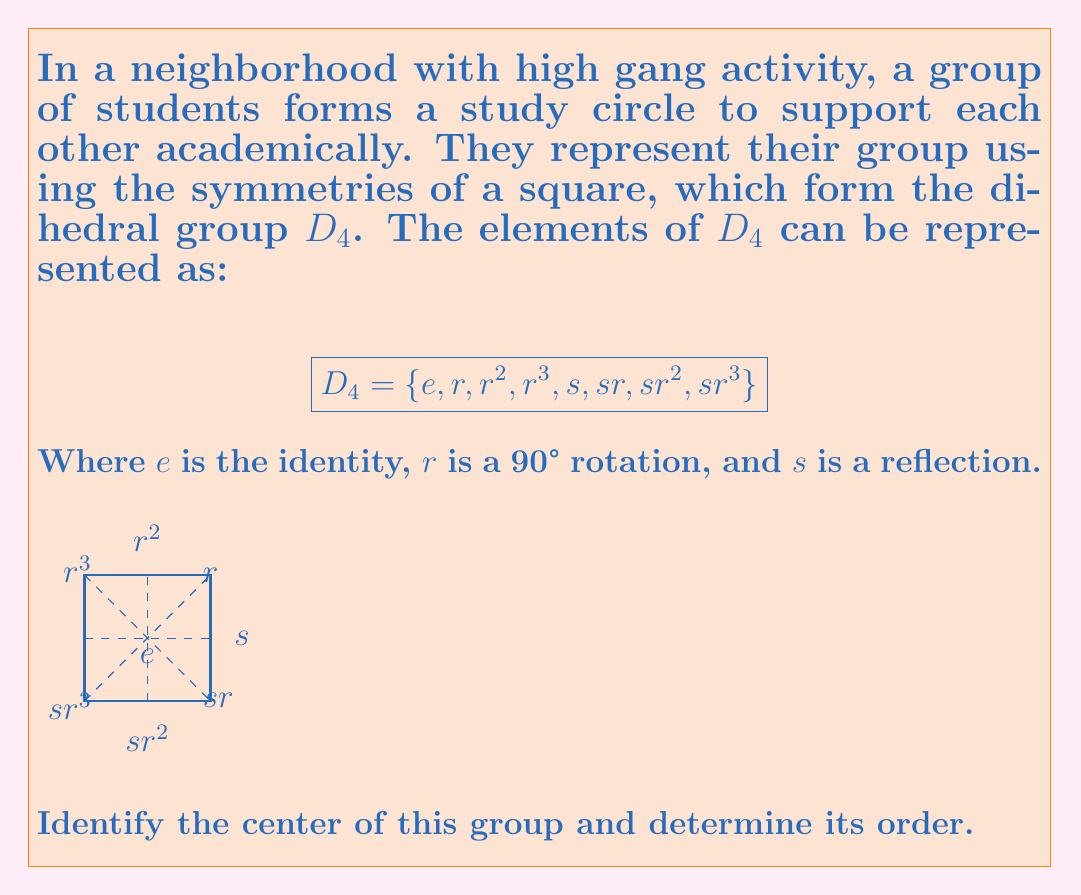Help me with this question. To find the center of the group $D_4$, we need to identify all elements that commute with every other element in the group. Let's go through this step-by-step:

1) The identity element $e$ always commutes with all elements, so it's in the center.

2) Let's check $r^2$ (180° rotation):
   - $r^2r = rr^2$
   - $r^2s = sr^2$
   These hold for all combinations, so $r^2$ is in the center.

3) For $r$ and $r^3$:
   $rs \neq sr$, so they're not in the center.

4) For $s, sr, sr^2, sr^3$:
   These don't commute with rotations, so they're not in the center.

Therefore, the center of $D_4$ is $\{e, r^2\}$.

To determine its order:
The order of a group is the number of elements it contains. The center we found has 2 elements, so its order is 2.

This result shows that in the study circle, only the identity operation (doing nothing) and rotating the square 180° are operations that "get along" with all other operations, symbolizing the core stability in the group despite external pressures.
Answer: Center: $\{e, r^2\}$, Order: 2 